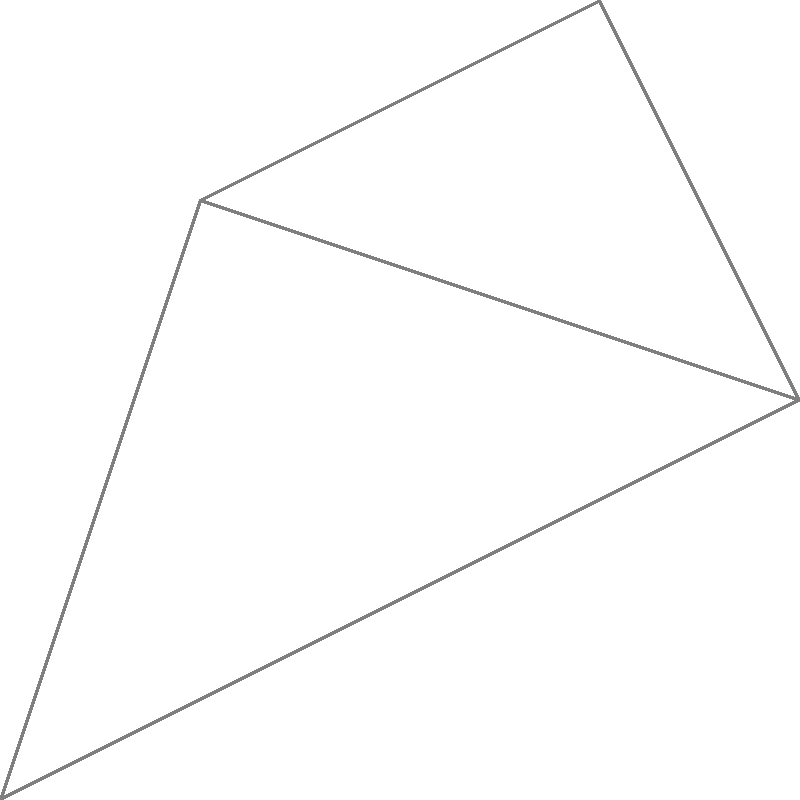In a city with five popular coffee houses known for their live music, you want to model the locations as nodes and the travel distances between them as edges in a graph. The diagram shows the network of coffee houses (A, B, C, D, E) and the distances between them. What is the minimum total distance required to visit all coffee houses, starting from coffee house A and ending at coffee house E, without revisiting any coffee house? To find the minimum total distance, we need to determine the shortest path that visits all coffee houses exactly once, starting at A and ending at E. This is a variation of the Traveling Salesman Problem. Let's approach this step-by-step:

1. Start at coffee house A.

2. We have two options from A: go to B (distance 3) or C (distance 4).
   Let's explore both paths:

   Path 1: A → B
   - From B, we must go to D (distance 5)
   - From D, we can go to C or E
     - If D → C → E: total distance = 3 + 5 + 2 + 3 = 13
     - If D → E: total distance = 3 + 5 + 1 = 9 (but we miss C)

   Path 2: A → C
   - From C, we can go to D or E
     - If C → D → E: total distance = 4 + 2 + 1 = 7
     - If C → E → D: total distance = 4 + 3 + 1 = 8

3. The shortest path that visits all coffee houses is:
   A → C → D → E

4. Calculate the total distance:
   A to C: 4
   C to D: 2
   D to E: 1
   Total: 4 + 2 + 1 = 7

Therefore, the minimum total distance required to visit all coffee houses, starting from A and ending at E, without revisiting any coffee house is 7 units.
Answer: 7 units 